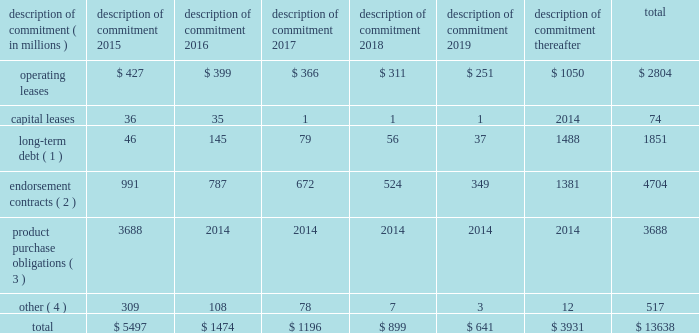Part ii on november 1 , 2011 , we entered into a committed credit facility agreement with a syndicate of banks which provides for up to $ 1 billion of borrowings with the option to increase borrowings to $ 1.5 billion with lender approval .
Following an extension agreement on september 17 , 2013 between the company and the syndicate of banks , the facility matures november 1 , 2017 , with a one-year extension option exercisable through october 31 , 2014 .
No amounts were outstanding under this facility as of may 31 , 2014 or 2013 .
We currently have long-term debt ratings of aa- and a1 from standard and poor 2019s corporation and moody 2019s investor services , respectively .
If our long- term debt rating were to decline , the facility fee and interest rate under our committed credit facility would increase .
Conversely , if our long-term debt rating were to improve , the facility fee and interest rate would decrease .
Changes in our long-term debt rating would not trigger acceleration of maturity of any then-outstanding borrowings or any future borrowings under the committed credit facility .
Under this committed revolving credit facility , we have agreed to various covenants .
These covenants include limits on our disposal of fixed assets , the amount of debt secured by liens we may incur , as well as a minimum capitalization ratio .
In the event we were to have any borrowings outstanding under this facility and failed to meet any covenant , and were unable to obtain a waiver from a majority of the banks in the syndicate , any borrowings would become immediately due and payable .
As of may 31 , 2014 , we were in full compliance with each of these covenants and believe it is unlikely we will fail to meet any of these covenants in the foreseeable future .
Liquidity is also provided by our $ 1 billion commercial paper program .
During the year ended may 31 , 2014 , we did not issue commercial paper , and as of may 31 , 2014 , there were no outstanding borrowings under this program .
We may continue to issue commercial paper or other debt securities during fiscal 2015 depending on general corporate needs .
We currently have short-term debt ratings of a1+ and p1 from standard and poor 2019s corporation and moody 2019s investor services , respectively .
As of may 31 , 2014 , we had cash , cash equivalents , and short-term investments totaling $ 5.1 billion , of which $ 2.5 billion was held by our foreign subsidiaries .
Cash equivalents and short-term investments consist primarily of deposits held at major banks , money market funds , commercial paper , corporate notes , u.s .
Treasury obligations , u.s .
Government sponsored enterprise obligations , and other investment grade fixed income securities .
Our fixed income investments are exposed to both credit and interest rate risk .
All of our investments are investment grade to minimize our credit risk .
While individual securities have varying durations , as of may 31 , 2014 the average duration of our short-term investments and cash equivalents portfolio was 126 days .
To date we have not experienced difficulty accessing the credit markets or incurred higher interest costs .
Future volatility in the capital markets , however , may increase costs associated with issuing commercial paper or other debt instruments or affect our ability to access those markets .
We believe that existing cash , cash equivalents , short-term investments , and cash generated by operations , together with access to external sources of funds as described above , will be sufficient to meet our domestic and foreign capital needs in the foreseeable future .
We utilize a variety of tax planning and financing strategies to manage our worldwide cash and deploy funds to locations where they are needed .
We routinely repatriate a portion of our foreign earnings for which u.s .
Taxes have previously been provided .
We also indefinitely reinvest a significant portion of our foreign earnings , and our current plans do not demonstrate a need to repatriate these earnings .
Should we require additional capital in the united states , we may elect to repatriate indefinitely reinvested foreign funds or raise capital in the united states through debt .
If we were to repatriate indefinitely reinvested foreign funds , we would be required to accrue and pay additional u.s .
Taxes less applicable foreign tax credits .
If we elect to raise capital in the united states through debt , we would incur additional interest expense .
Off-balance sheet arrangements in connection with various contracts and agreements , we routinely provide indemnification relating to the enforceability of intellectual property rights , coverage for legal issues that arise and other items where we are acting as the guarantor .
Currently , we have several such agreements in place .
However , based on our historical experience and the estimated probability of future loss , we have determined that the fair value of such indemnification is not material to our financial position or results of operations .
Contractual obligations our significant long-term contractual obligations as of may 31 , 2014 and significant endorsement contracts entered into through the date of this report are as follows: .
( 1 ) the cash payments due for long-term debt include estimated interest payments .
Estimates of interest payments are based on outstanding principal amounts , applicable fixed interest rates or currently effective interest rates as of may 31 , 2014 ( if variable ) , timing of scheduled payments , and the term of the debt obligations .
( 2 ) the amounts listed for endorsement contracts represent approximate amounts of base compensation and minimum guaranteed royalty fees we are obligated to pay athlete and sport team endorsers of our products .
Actual payments under some contracts may be higher than the amounts listed as these contracts provide for bonuses to be paid to the endorsers based upon athletic achievements and/or royalties on product sales in future periods .
Actual payments under some contracts may also be lower as these contracts include provisions for reduced payments if athletic performance declines in future periods .
In addition to the cash payments , we are obligated to furnish our endorsers with nike product for their use .
It is not possible to determine how much we will spend on this product on an annual basis as the contracts generally do not stipulate a specific amount of cash to be spent on the product .
The amount of product provided to the endorsers will depend on many factors , including general playing conditions , the number of sporting events in which they participate , and our own decisions regarding product and marketing initiatives .
In addition , the costs to design , develop , source , and purchase the products furnished to the endorsers are incurred over a period of time and are not necessarily tracked separately from similar costs incurred for products sold to customers .
( 3 ) we generally order product at least four to five months in advance of sale based primarily on futures orders received from customers .
The amounts listed for product purchase obligations represent agreements ( including open purchase orders ) to purchase products in the ordinary course of business that are enforceable and legally binding and that specify all significant terms .
In some cases , prices are subject to change throughout the production process .
The reported amounts exclude product purchase liabilities included in accounts payable on the consolidated balance sheet as of may 31 , 2014 .
( 4 ) other amounts primarily include service and marketing commitments made in the ordinary course of business .
The amounts represent the minimum payments required by legally binding contracts and agreements that specify all significant terms , including open purchase orders for non-product purchases .
The reported amounts exclude those liabilities included in accounts payable or accrued liabilities on the consolidated balance sheet as of may 31 , 2014 .
Nike , inc .
2014 annual report and notice of annual meeting 79 .
What percentage of capital leases are due in 2016? 
Computations: (35 / 74)
Answer: 0.47297. 